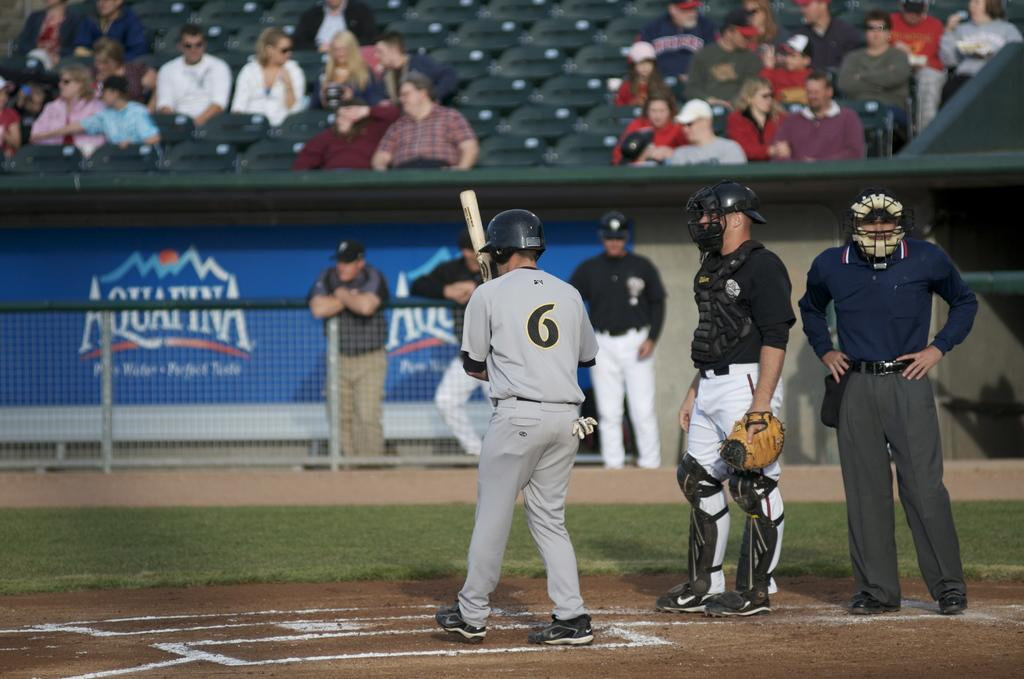<image>
Provide a brief description of the given image. Player number 6 is up at bat in front of an Aquafina ad. 